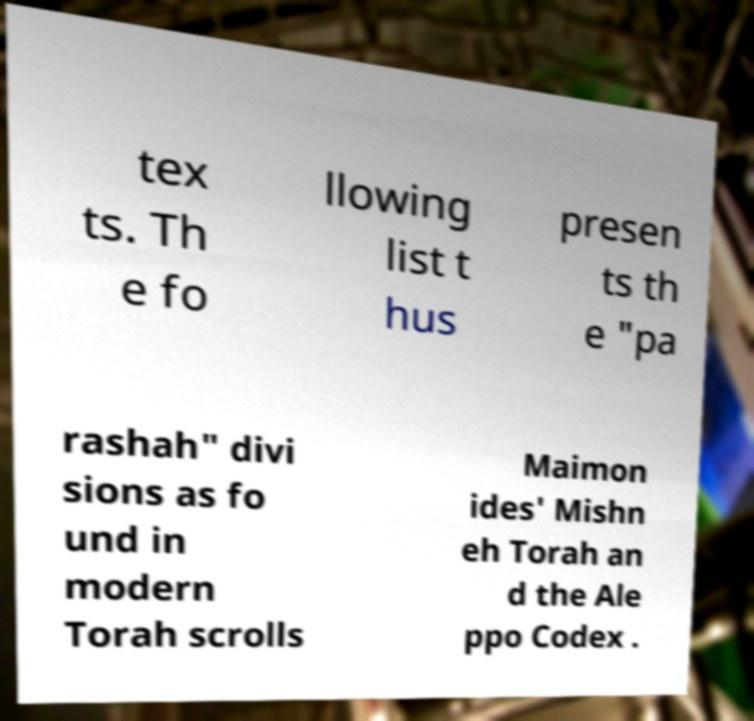There's text embedded in this image that I need extracted. Can you transcribe it verbatim? tex ts. Th e fo llowing list t hus presen ts th e "pa rashah" divi sions as fo und in modern Torah scrolls Maimon ides' Mishn eh Torah an d the Ale ppo Codex . 